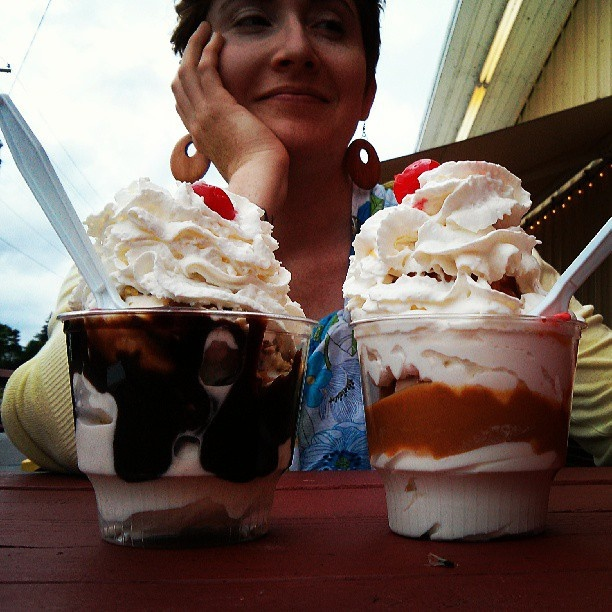Describe the objects in this image and their specific colors. I can see dining table in white, black, maroon, lightgray, and darkgray tones, cup in white, black, maroon, gray, and darkgray tones, people in white, black, maroon, and brown tones, cup in white, maroon, black, gray, and darkgray tones, and spoon in white, darkgray, gray, and lightblue tones in this image. 